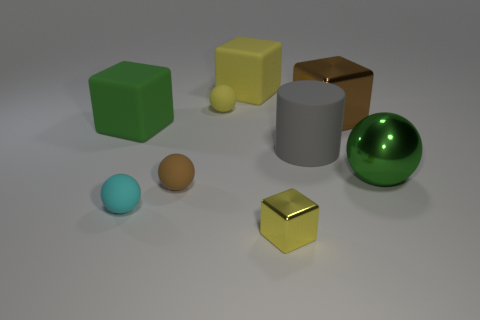What size is the brown thing that is behind the big object that is to the right of the big brown metal object?
Ensure brevity in your answer.  Large. What is the material of the cube that is to the right of the yellow matte cube and to the left of the brown metallic block?
Offer a terse response. Metal. How many other objects are there of the same size as the green rubber object?
Give a very brief answer. 4. What is the color of the large shiny cube?
Your answer should be compact. Brown. There is a metal ball that is behind the cyan matte thing; is it the same color as the large rubber block that is left of the brown sphere?
Give a very brief answer. Yes. The yellow rubber sphere is what size?
Ensure brevity in your answer.  Small. There is a matte sphere that is behind the brown rubber thing; what size is it?
Ensure brevity in your answer.  Small. What shape is the object that is both on the left side of the tiny brown sphere and behind the tiny cyan thing?
Ensure brevity in your answer.  Cube. What number of other things are the same shape as the yellow shiny object?
Provide a succinct answer. 3. What color is the shiny sphere that is the same size as the gray object?
Ensure brevity in your answer.  Green. 